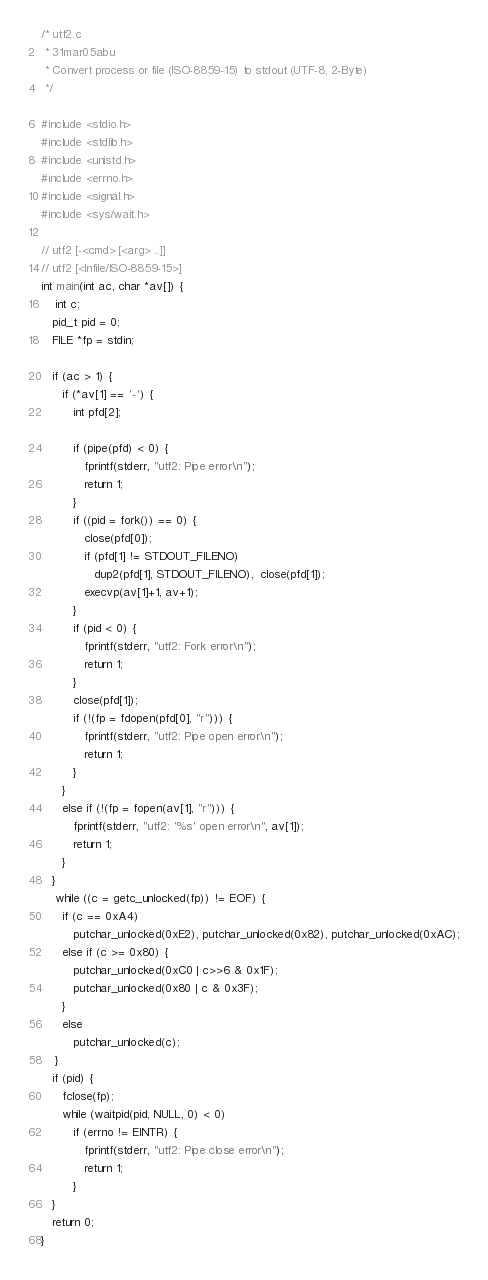<code> <loc_0><loc_0><loc_500><loc_500><_C_>/* utf2.c
 * 31mar05abu
 * Convert process or file (ISO-8859-15) to stdout (UTF-8, 2-Byte)
 */

#include <stdio.h>
#include <stdlib.h>
#include <unistd.h>
#include <errno.h>
#include <signal.h>
#include <sys/wait.h>

// utf2 [-<cmd> [<arg> ..]]
// utf2 [<Infile/ISO-8859-15>]
int main(int ac, char *av[]) {
	int c;
   pid_t pid = 0;
   FILE *fp = stdin;

   if (ac > 1) {
      if (*av[1] == '-') {
         int pfd[2];

         if (pipe(pfd) < 0) {
            fprintf(stderr, "utf2: Pipe error\n");
            return 1;
         }
         if ((pid = fork()) == 0) {
            close(pfd[0]);
            if (pfd[1] != STDOUT_FILENO)
               dup2(pfd[1], STDOUT_FILENO),  close(pfd[1]);
            execvp(av[1]+1, av+1);
         }
         if (pid < 0) {
            fprintf(stderr, "utf2: Fork error\n");
            return 1;
         }
         close(pfd[1]);
         if (!(fp = fdopen(pfd[0], "r"))) {
            fprintf(stderr, "utf2: Pipe open error\n");
            return 1;
         }
      }
      else if (!(fp = fopen(av[1], "r"))) {
         fprintf(stderr, "utf2: '%s' open error\n", av[1]);
         return 1;
      }
   }
	while ((c = getc_unlocked(fp)) != EOF) {
      if (c == 0xA4)
         putchar_unlocked(0xE2), putchar_unlocked(0x82), putchar_unlocked(0xAC);
      else if (c >= 0x80) {
         putchar_unlocked(0xC0 | c>>6 & 0x1F);
         putchar_unlocked(0x80 | c & 0x3F);
      }
      else
         putchar_unlocked(c);
	}
   if (pid) {
      fclose(fp);
      while (waitpid(pid, NULL, 0) < 0)
         if (errno != EINTR) {
            fprintf(stderr, "utf2: Pipe close error\n");
            return 1;
         }
   }
   return 0;
}
</code> 